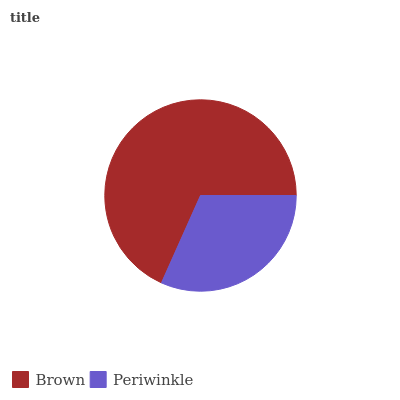Is Periwinkle the minimum?
Answer yes or no. Yes. Is Brown the maximum?
Answer yes or no. Yes. Is Periwinkle the maximum?
Answer yes or no. No. Is Brown greater than Periwinkle?
Answer yes or no. Yes. Is Periwinkle less than Brown?
Answer yes or no. Yes. Is Periwinkle greater than Brown?
Answer yes or no. No. Is Brown less than Periwinkle?
Answer yes or no. No. Is Brown the high median?
Answer yes or no. Yes. Is Periwinkle the low median?
Answer yes or no. Yes. Is Periwinkle the high median?
Answer yes or no. No. Is Brown the low median?
Answer yes or no. No. 